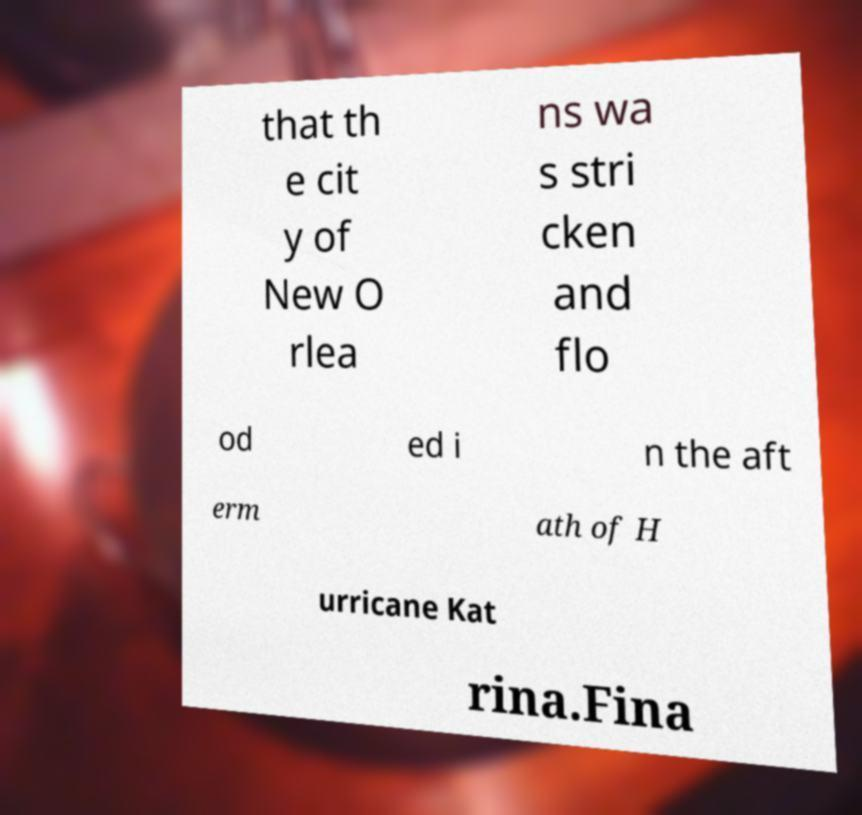Can you accurately transcribe the text from the provided image for me? that th e cit y of New O rlea ns wa s stri cken and flo od ed i n the aft erm ath of H urricane Kat rina.Fina 